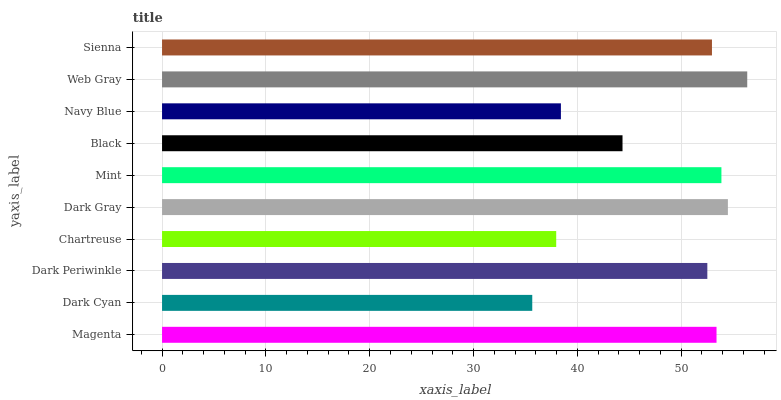Is Dark Cyan the minimum?
Answer yes or no. Yes. Is Web Gray the maximum?
Answer yes or no. Yes. Is Dark Periwinkle the minimum?
Answer yes or no. No. Is Dark Periwinkle the maximum?
Answer yes or no. No. Is Dark Periwinkle greater than Dark Cyan?
Answer yes or no. Yes. Is Dark Cyan less than Dark Periwinkle?
Answer yes or no. Yes. Is Dark Cyan greater than Dark Periwinkle?
Answer yes or no. No. Is Dark Periwinkle less than Dark Cyan?
Answer yes or no. No. Is Sienna the high median?
Answer yes or no. Yes. Is Dark Periwinkle the low median?
Answer yes or no. Yes. Is Chartreuse the high median?
Answer yes or no. No. Is Chartreuse the low median?
Answer yes or no. No. 